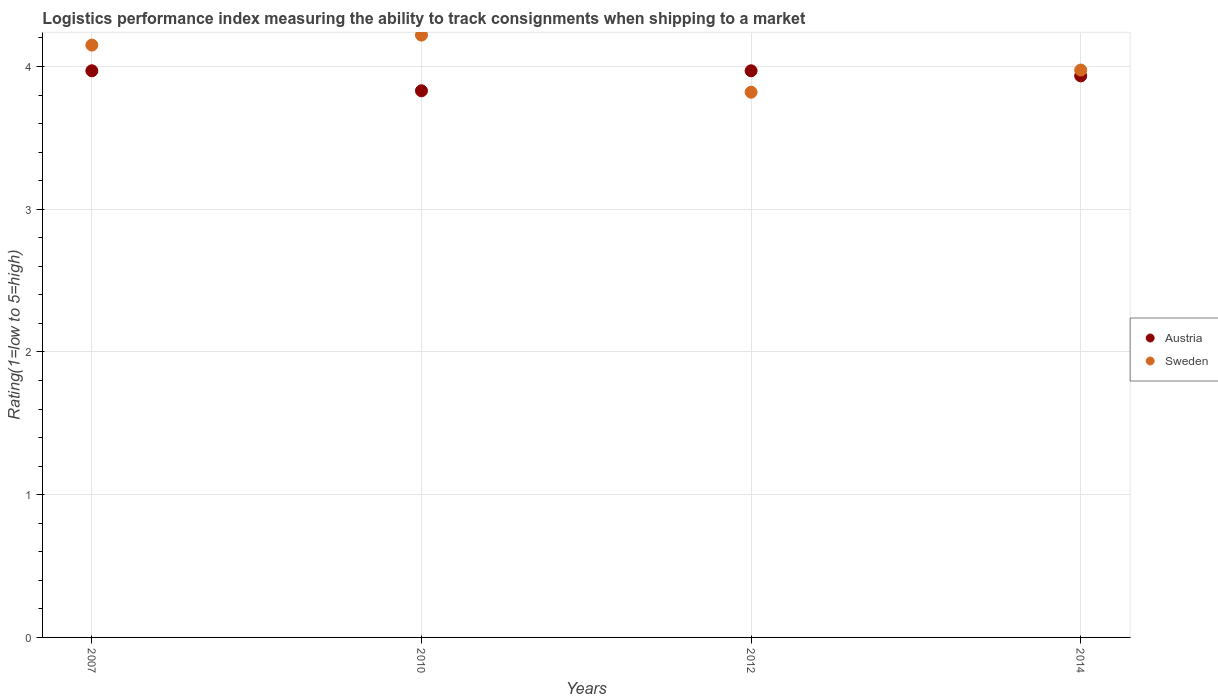Is the number of dotlines equal to the number of legend labels?
Your answer should be compact. Yes. What is the Logistic performance index in Sweden in 2014?
Your response must be concise. 3.98. Across all years, what is the maximum Logistic performance index in Austria?
Provide a succinct answer. 3.97. Across all years, what is the minimum Logistic performance index in Austria?
Keep it short and to the point. 3.83. In which year was the Logistic performance index in Sweden minimum?
Offer a terse response. 2012. What is the total Logistic performance index in Austria in the graph?
Make the answer very short. 15.7. What is the difference between the Logistic performance index in Sweden in 2007 and that in 2014?
Provide a short and direct response. 0.18. What is the difference between the Logistic performance index in Sweden in 2014 and the Logistic performance index in Austria in 2007?
Keep it short and to the point. 0. What is the average Logistic performance index in Sweden per year?
Offer a terse response. 4.04. In the year 2014, what is the difference between the Logistic performance index in Sweden and Logistic performance index in Austria?
Ensure brevity in your answer.  0.04. In how many years, is the Logistic performance index in Sweden greater than 1.4?
Offer a very short reply. 4. What is the ratio of the Logistic performance index in Sweden in 2010 to that in 2012?
Your answer should be very brief. 1.1. What is the difference between the highest and the second highest Logistic performance index in Sweden?
Ensure brevity in your answer.  0.07. What is the difference between the highest and the lowest Logistic performance index in Austria?
Keep it short and to the point. 0.14. In how many years, is the Logistic performance index in Austria greater than the average Logistic performance index in Austria taken over all years?
Keep it short and to the point. 3. Does the Logistic performance index in Sweden monotonically increase over the years?
Provide a succinct answer. No. Is the Logistic performance index in Austria strictly greater than the Logistic performance index in Sweden over the years?
Make the answer very short. No. What is the difference between two consecutive major ticks on the Y-axis?
Your answer should be very brief. 1. Are the values on the major ticks of Y-axis written in scientific E-notation?
Provide a short and direct response. No. Does the graph contain grids?
Offer a terse response. Yes. How many legend labels are there?
Provide a succinct answer. 2. How are the legend labels stacked?
Give a very brief answer. Vertical. What is the title of the graph?
Provide a short and direct response. Logistics performance index measuring the ability to track consignments when shipping to a market. What is the label or title of the Y-axis?
Offer a very short reply. Rating(1=low to 5=high). What is the Rating(1=low to 5=high) of Austria in 2007?
Your response must be concise. 3.97. What is the Rating(1=low to 5=high) in Sweden in 2007?
Keep it short and to the point. 4.15. What is the Rating(1=low to 5=high) in Austria in 2010?
Keep it short and to the point. 3.83. What is the Rating(1=low to 5=high) of Sweden in 2010?
Make the answer very short. 4.22. What is the Rating(1=low to 5=high) in Austria in 2012?
Give a very brief answer. 3.97. What is the Rating(1=low to 5=high) in Sweden in 2012?
Ensure brevity in your answer.  3.82. What is the Rating(1=low to 5=high) in Austria in 2014?
Keep it short and to the point. 3.93. What is the Rating(1=low to 5=high) of Sweden in 2014?
Provide a succinct answer. 3.98. Across all years, what is the maximum Rating(1=low to 5=high) of Austria?
Give a very brief answer. 3.97. Across all years, what is the maximum Rating(1=low to 5=high) of Sweden?
Give a very brief answer. 4.22. Across all years, what is the minimum Rating(1=low to 5=high) of Austria?
Offer a very short reply. 3.83. Across all years, what is the minimum Rating(1=low to 5=high) of Sweden?
Give a very brief answer. 3.82. What is the total Rating(1=low to 5=high) of Austria in the graph?
Make the answer very short. 15.7. What is the total Rating(1=low to 5=high) in Sweden in the graph?
Provide a short and direct response. 16.16. What is the difference between the Rating(1=low to 5=high) of Austria in 2007 and that in 2010?
Make the answer very short. 0.14. What is the difference between the Rating(1=low to 5=high) of Sweden in 2007 and that in 2010?
Your answer should be very brief. -0.07. What is the difference between the Rating(1=low to 5=high) of Austria in 2007 and that in 2012?
Ensure brevity in your answer.  0. What is the difference between the Rating(1=low to 5=high) of Sweden in 2007 and that in 2012?
Offer a terse response. 0.33. What is the difference between the Rating(1=low to 5=high) of Austria in 2007 and that in 2014?
Your answer should be very brief. 0.04. What is the difference between the Rating(1=low to 5=high) in Sweden in 2007 and that in 2014?
Your answer should be compact. 0.17. What is the difference between the Rating(1=low to 5=high) in Austria in 2010 and that in 2012?
Make the answer very short. -0.14. What is the difference between the Rating(1=low to 5=high) in Austria in 2010 and that in 2014?
Offer a very short reply. -0.1. What is the difference between the Rating(1=low to 5=high) of Sweden in 2010 and that in 2014?
Give a very brief answer. 0.24. What is the difference between the Rating(1=low to 5=high) of Austria in 2012 and that in 2014?
Your answer should be compact. 0.04. What is the difference between the Rating(1=low to 5=high) in Sweden in 2012 and that in 2014?
Offer a very short reply. -0.15. What is the difference between the Rating(1=low to 5=high) of Austria in 2007 and the Rating(1=low to 5=high) of Sweden in 2010?
Ensure brevity in your answer.  -0.25. What is the difference between the Rating(1=low to 5=high) of Austria in 2007 and the Rating(1=low to 5=high) of Sweden in 2012?
Your answer should be compact. 0.15. What is the difference between the Rating(1=low to 5=high) of Austria in 2007 and the Rating(1=low to 5=high) of Sweden in 2014?
Your response must be concise. -0.01. What is the difference between the Rating(1=low to 5=high) of Austria in 2010 and the Rating(1=low to 5=high) of Sweden in 2014?
Provide a short and direct response. -0.14. What is the difference between the Rating(1=low to 5=high) in Austria in 2012 and the Rating(1=low to 5=high) in Sweden in 2014?
Offer a terse response. -0.01. What is the average Rating(1=low to 5=high) in Austria per year?
Offer a terse response. 3.93. What is the average Rating(1=low to 5=high) of Sweden per year?
Keep it short and to the point. 4.04. In the year 2007, what is the difference between the Rating(1=low to 5=high) in Austria and Rating(1=low to 5=high) in Sweden?
Offer a very short reply. -0.18. In the year 2010, what is the difference between the Rating(1=low to 5=high) in Austria and Rating(1=low to 5=high) in Sweden?
Your answer should be very brief. -0.39. In the year 2012, what is the difference between the Rating(1=low to 5=high) in Austria and Rating(1=low to 5=high) in Sweden?
Your response must be concise. 0.15. In the year 2014, what is the difference between the Rating(1=low to 5=high) in Austria and Rating(1=low to 5=high) in Sweden?
Your response must be concise. -0.04. What is the ratio of the Rating(1=low to 5=high) of Austria in 2007 to that in 2010?
Offer a very short reply. 1.04. What is the ratio of the Rating(1=low to 5=high) of Sweden in 2007 to that in 2010?
Make the answer very short. 0.98. What is the ratio of the Rating(1=low to 5=high) of Sweden in 2007 to that in 2012?
Offer a terse response. 1.09. What is the ratio of the Rating(1=low to 5=high) in Austria in 2007 to that in 2014?
Your answer should be compact. 1.01. What is the ratio of the Rating(1=low to 5=high) in Sweden in 2007 to that in 2014?
Your response must be concise. 1.04. What is the ratio of the Rating(1=low to 5=high) of Austria in 2010 to that in 2012?
Offer a terse response. 0.96. What is the ratio of the Rating(1=low to 5=high) of Sweden in 2010 to that in 2012?
Your answer should be very brief. 1.1. What is the ratio of the Rating(1=low to 5=high) of Austria in 2010 to that in 2014?
Make the answer very short. 0.97. What is the ratio of the Rating(1=low to 5=high) in Sweden in 2010 to that in 2014?
Make the answer very short. 1.06. What is the ratio of the Rating(1=low to 5=high) of Austria in 2012 to that in 2014?
Your answer should be very brief. 1.01. What is the difference between the highest and the second highest Rating(1=low to 5=high) in Austria?
Offer a terse response. 0. What is the difference between the highest and the second highest Rating(1=low to 5=high) in Sweden?
Ensure brevity in your answer.  0.07. What is the difference between the highest and the lowest Rating(1=low to 5=high) in Austria?
Give a very brief answer. 0.14. What is the difference between the highest and the lowest Rating(1=low to 5=high) of Sweden?
Offer a very short reply. 0.4. 